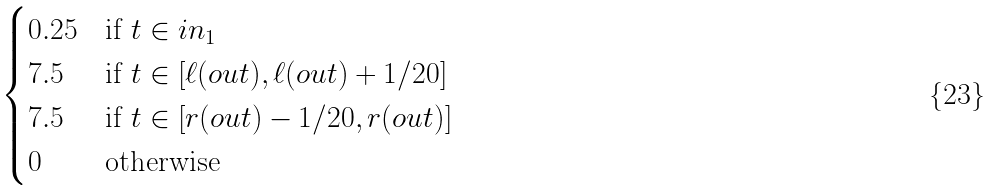Convert formula to latex. <formula><loc_0><loc_0><loc_500><loc_500>\begin{cases} 0 . 2 5 & \text {if } t \in i n _ { 1 } \\ 7 . 5 & \text {if } t \in [ \ell ( o u t ) , \ell ( o u t ) + 1 / 2 0 ] \\ 7 . 5 & \text {if } t \in [ r ( o u t ) - 1 / 2 0 , r ( o u t ) ] \\ 0 & \text {otherwise} \end{cases}</formula> 